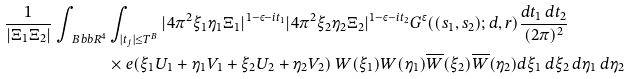<formula> <loc_0><loc_0><loc_500><loc_500>\frac { 1 } { | \Xi _ { 1 } \Xi _ { 2 } | } \int _ { \ B b b { R } ^ { 4 } } & \int _ { | t _ { j } | \leq T ^ { B } } | 4 \pi ^ { 2 } \xi _ { 1 } \eta _ { 1 } \Xi _ { 1 } | ^ { 1 - \varepsilon - i t _ { 1 } } | 4 \pi ^ { 2 } \xi _ { 2 } \eta _ { 2 } \Xi _ { 2 } | ^ { 1 - \varepsilon - i t _ { 2 } } G ^ { \epsilon } ( ( s _ { 1 } , s _ { 2 } ) ; d , r ) \frac { d t _ { 1 } \, d t _ { 2 } } { ( 2 \pi ) ^ { 2 } } \\ & \times e ( \xi _ { 1 } U _ { 1 } + \eta _ { 1 } V _ { 1 } + \xi _ { 2 } U _ { 2 } + \eta _ { 2 } V _ { 2 } ) \ W ( \xi _ { 1 } ) W ( \eta _ { 1 } ) \overline { W } ( \xi _ { 2 } ) \overline { W } ( \eta _ { 2 } ) d \xi _ { 1 } \, d \xi _ { 2 } \, d \eta _ { 1 } \, d \eta _ { 2 }</formula> 